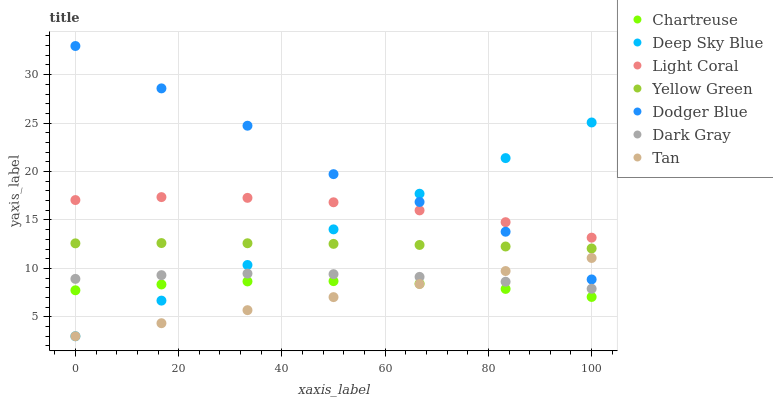Does Tan have the minimum area under the curve?
Answer yes or no. Yes. Does Dodger Blue have the maximum area under the curve?
Answer yes or no. Yes. Does Yellow Green have the minimum area under the curve?
Answer yes or no. No. Does Yellow Green have the maximum area under the curve?
Answer yes or no. No. Is Deep Sky Blue the smoothest?
Answer yes or no. Yes. Is Dodger Blue the roughest?
Answer yes or no. Yes. Is Yellow Green the smoothest?
Answer yes or no. No. Is Yellow Green the roughest?
Answer yes or no. No. Does Deep Sky Blue have the lowest value?
Answer yes or no. Yes. Does Yellow Green have the lowest value?
Answer yes or no. No. Does Dodger Blue have the highest value?
Answer yes or no. Yes. Does Yellow Green have the highest value?
Answer yes or no. No. Is Chartreuse less than Yellow Green?
Answer yes or no. Yes. Is Dodger Blue greater than Chartreuse?
Answer yes or no. Yes. Does Yellow Green intersect Deep Sky Blue?
Answer yes or no. Yes. Is Yellow Green less than Deep Sky Blue?
Answer yes or no. No. Is Yellow Green greater than Deep Sky Blue?
Answer yes or no. No. Does Chartreuse intersect Yellow Green?
Answer yes or no. No. 